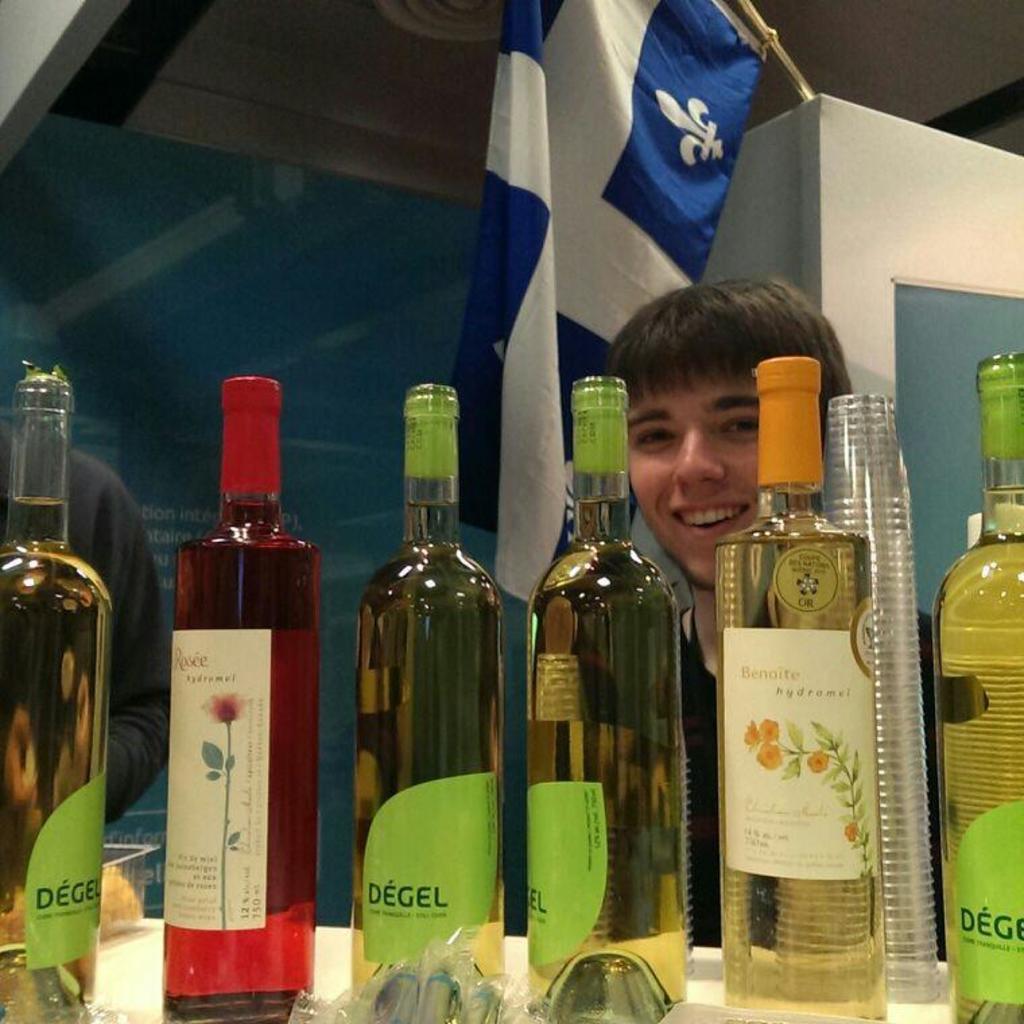What is the name of the drink in the bottles with the green labels on them?
Keep it short and to the point. Degel. What is the brand of the wine with the yellow flowers?
Offer a terse response. Benoite. 